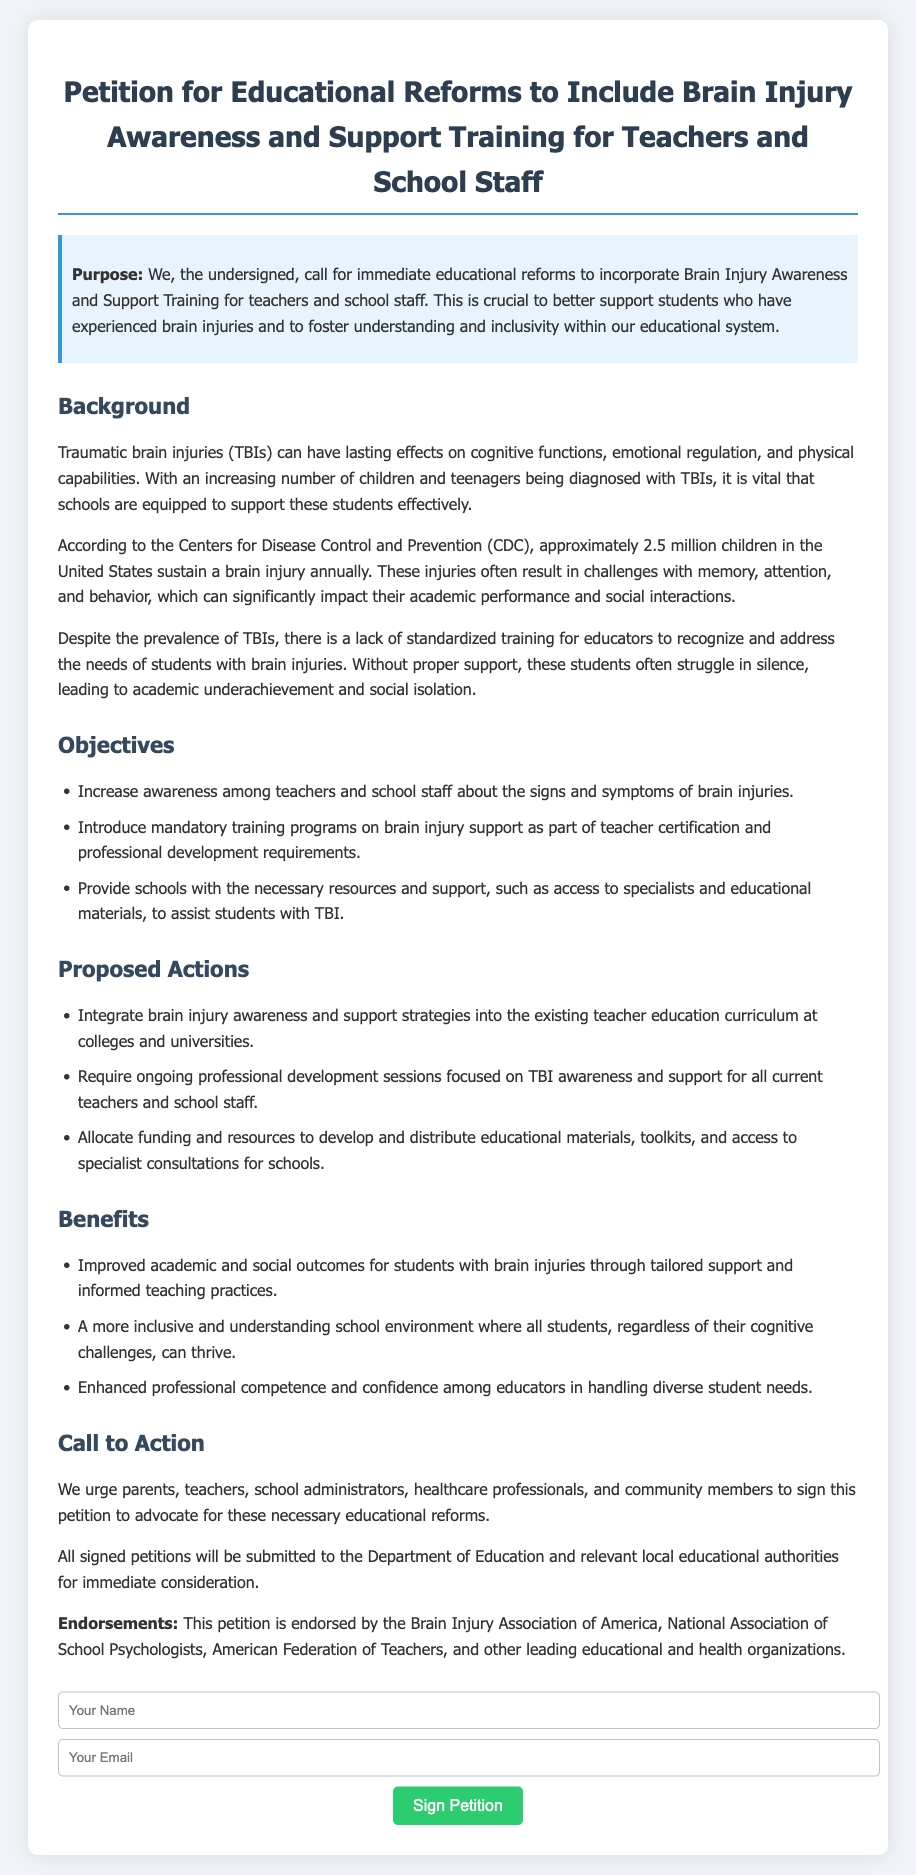What is the title of the petition? The title is a specific phrase mentioned at the beginning of the document.
Answer: Petition for Educational Reforms to Include Brain Injury Awareness and Support Training for Teachers and School Staff How many children in the U.S. sustain a brain injury annually? The document provides a statistical figure related to childhood brain injuries sourced from the CDC.
Answer: Approximately 2.5 million What is one of the objectives of the petition? The document lists specific goals aimed at educational reforms, which can be found under the objectives section.
Answer: Increase awareness among teachers and school staff about the signs and symptoms of brain injuries Which organization supports the petition? The document includes endorsements from various organizations for credibility and support.
Answer: Brain Injury Association of America What is proposed to be incorporated into teacher education curriculums? The petition outlines specific educational reforms that should be made to the teaching curriculum.
Answer: Brain injury awareness and support strategies What is one benefit outlined in the petition? The document details various advantages that would result from the proposed reforms, which are listed in the benefits section.
Answer: Improved academic and social outcomes for students with brain injuries What type of professionals are urged to sign the petition? The document specifies various stakeholders in the education and health sectors identified as important advocates for these reforms.
Answer: Parents, teachers, school administrators, healthcare professionals, and community members What funding purpose is mentioned in the petition? The document discusses resource allocation for specific educational needs related to brain injury support.
Answer: Develop and distribute educational materials, toolkits, and access to specialist consultations for schools 